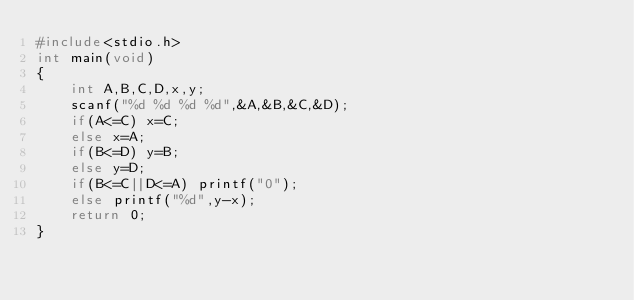<code> <loc_0><loc_0><loc_500><loc_500><_C_>#include<stdio.h>
int main(void)
{
    int A,B,C,D,x,y;
    scanf("%d %d %d %d",&A,&B,&C,&D);
    if(A<=C) x=C;
    else x=A;
    if(B<=D) y=B;
    else y=D;
    if(B<=C||D<=A) printf("0");
    else printf("%d",y-x);
    return 0;
}</code> 